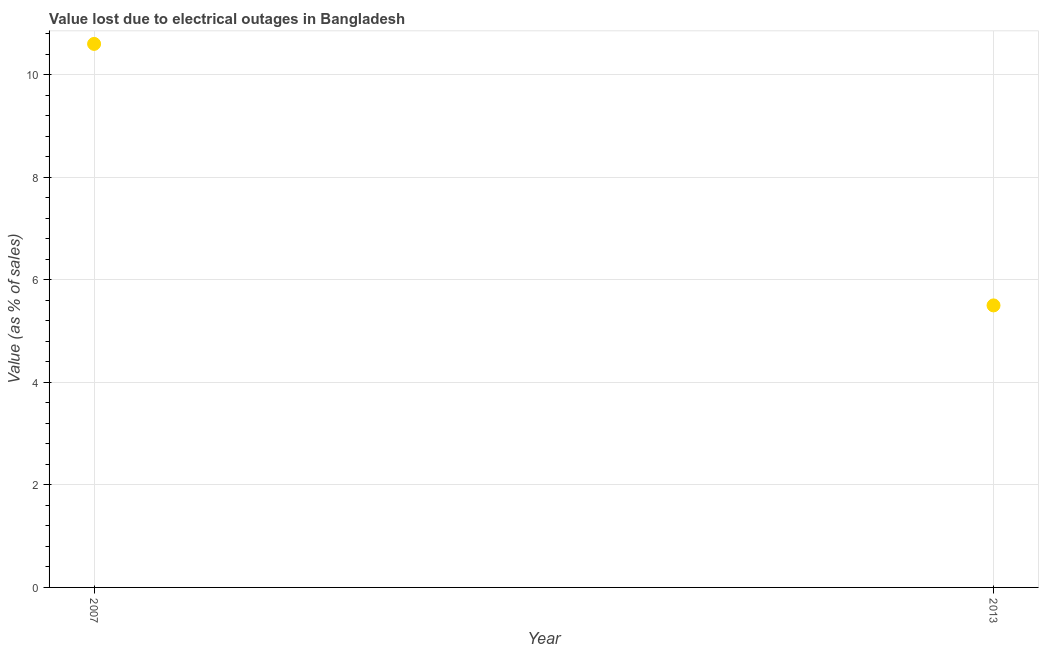Across all years, what is the maximum value lost due to electrical outages?
Your answer should be compact. 10.6. Across all years, what is the minimum value lost due to electrical outages?
Keep it short and to the point. 5.5. In which year was the value lost due to electrical outages minimum?
Ensure brevity in your answer.  2013. What is the difference between the value lost due to electrical outages in 2007 and 2013?
Give a very brief answer. 5.1. What is the average value lost due to electrical outages per year?
Provide a succinct answer. 8.05. What is the median value lost due to electrical outages?
Provide a short and direct response. 8.05. Do a majority of the years between 2013 and 2007 (inclusive) have value lost due to electrical outages greater than 5.2 %?
Ensure brevity in your answer.  No. What is the ratio of the value lost due to electrical outages in 2007 to that in 2013?
Make the answer very short. 1.93. Does the value lost due to electrical outages monotonically increase over the years?
Offer a very short reply. No. How many dotlines are there?
Your answer should be very brief. 1. How many years are there in the graph?
Keep it short and to the point. 2. What is the difference between two consecutive major ticks on the Y-axis?
Your answer should be compact. 2. Are the values on the major ticks of Y-axis written in scientific E-notation?
Offer a very short reply. No. Does the graph contain any zero values?
Your response must be concise. No. What is the title of the graph?
Make the answer very short. Value lost due to electrical outages in Bangladesh. What is the label or title of the X-axis?
Give a very brief answer. Year. What is the label or title of the Y-axis?
Keep it short and to the point. Value (as % of sales). What is the Value (as % of sales) in 2013?
Offer a very short reply. 5.5. What is the ratio of the Value (as % of sales) in 2007 to that in 2013?
Your answer should be compact. 1.93. 